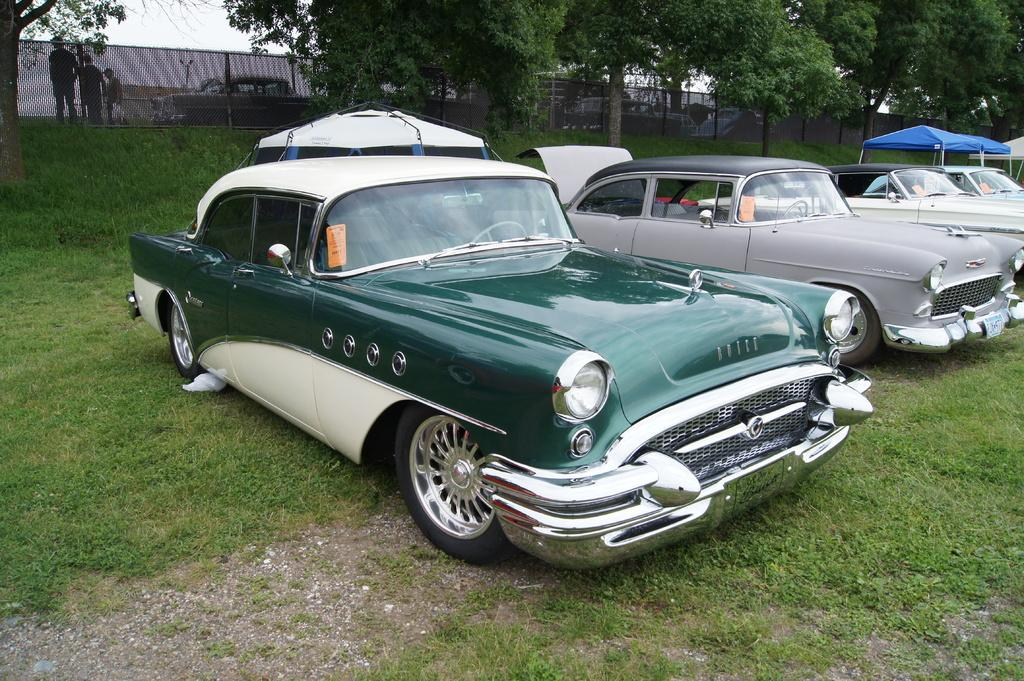What types of objects can be seen in the image? There are vehicles, trees, people, tents, and a fence in the image. What is the ground surface like in the image? The ground surface is covered with grass. What can be seen in the background of the image? The sky is visible in the background of the image. What type of shoe is being used to cover the appliance in the image? There is no shoe or appliance present in the image. 